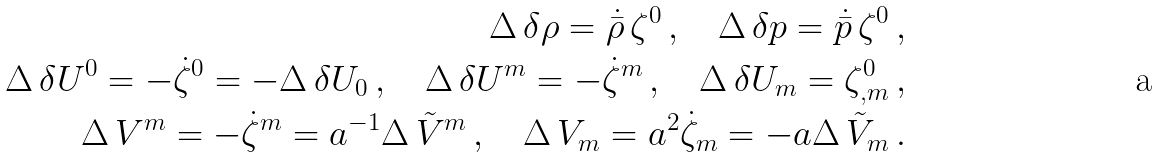<formula> <loc_0><loc_0><loc_500><loc_500>\Delta \, \delta \rho = \dot { \bar { \rho } } \, \zeta ^ { 0 } \, , \quad \Delta \, \delta p = \dot { \bar { p } } \, \zeta ^ { 0 } \, , \\ \Delta \, \delta U ^ { 0 } = - \dot { \zeta } ^ { 0 } = - \Delta \, \delta U _ { 0 } \, , \quad \Delta \, \delta U ^ { m } = - \dot { \zeta } ^ { m } \, , \quad \Delta \, \delta U _ { m } = \zeta ^ { 0 } _ { , m } \, , \\ \Delta \, V ^ { m } = - \dot { \zeta } ^ { m } = a ^ { - 1 } \Delta \, \tilde { V } ^ { m } \, , \quad \Delta \, V _ { m } = a ^ { 2 } \dot { \zeta } _ { m } = - a \Delta \, \tilde { V } _ { m } \, .</formula> 